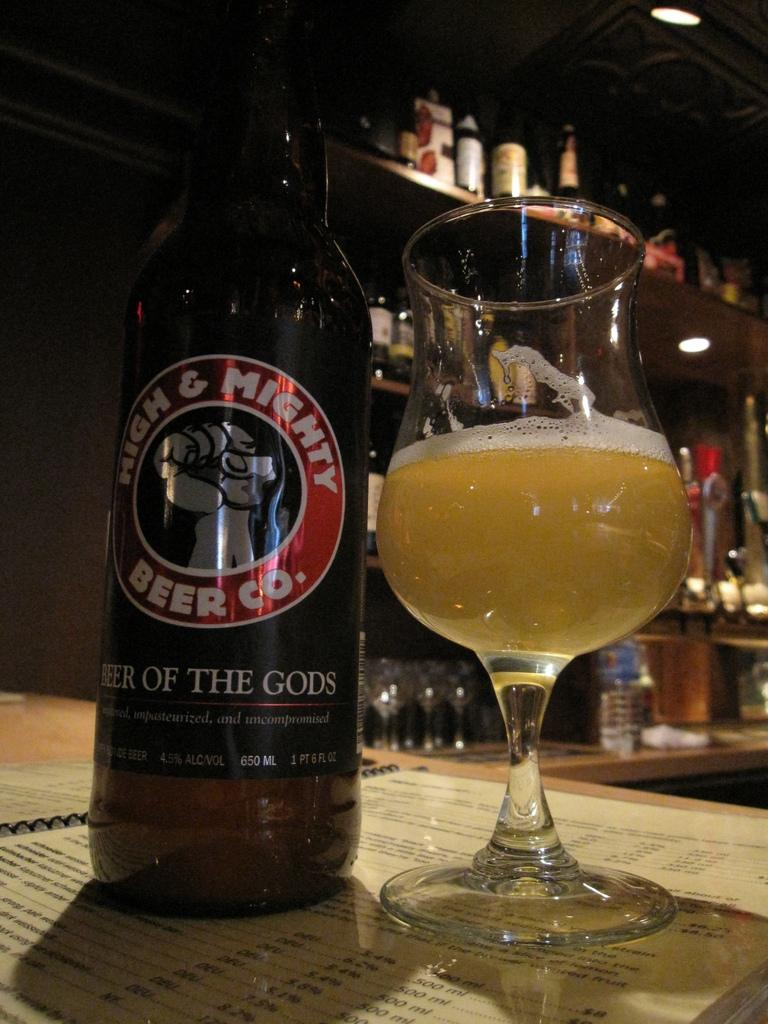What objects are on the table in the image? There is a bottle and a glass on the table in the image. What else can be seen in the image besides the bottle and glass? There is a card and a rack visible in the image. Where is the light source located in the image? The light source is in the image, but its exact location is not specified. What is the background of the image? The background of the image includes a rack. Is the writer of the card present in the image? There is no mention of a card being written or a writer being present in the image. 